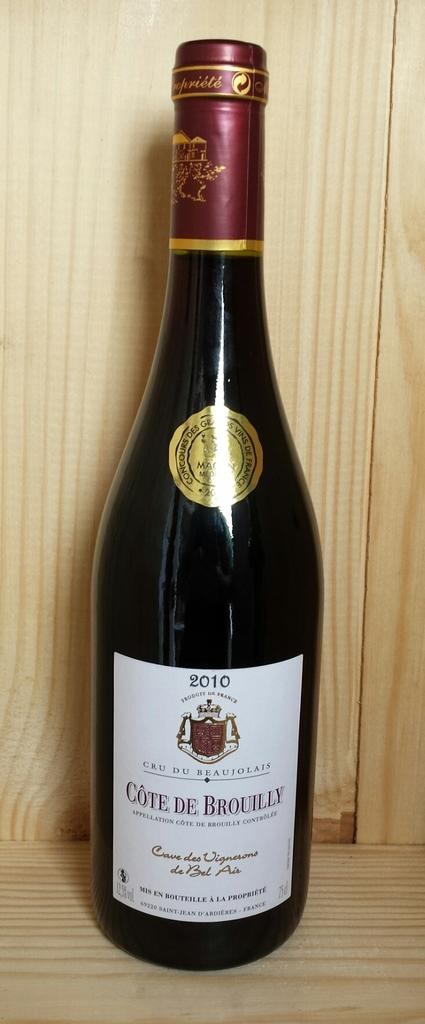<image>
Share a concise interpretation of the image provided. The bottle's label with the year 2010 at the top. 